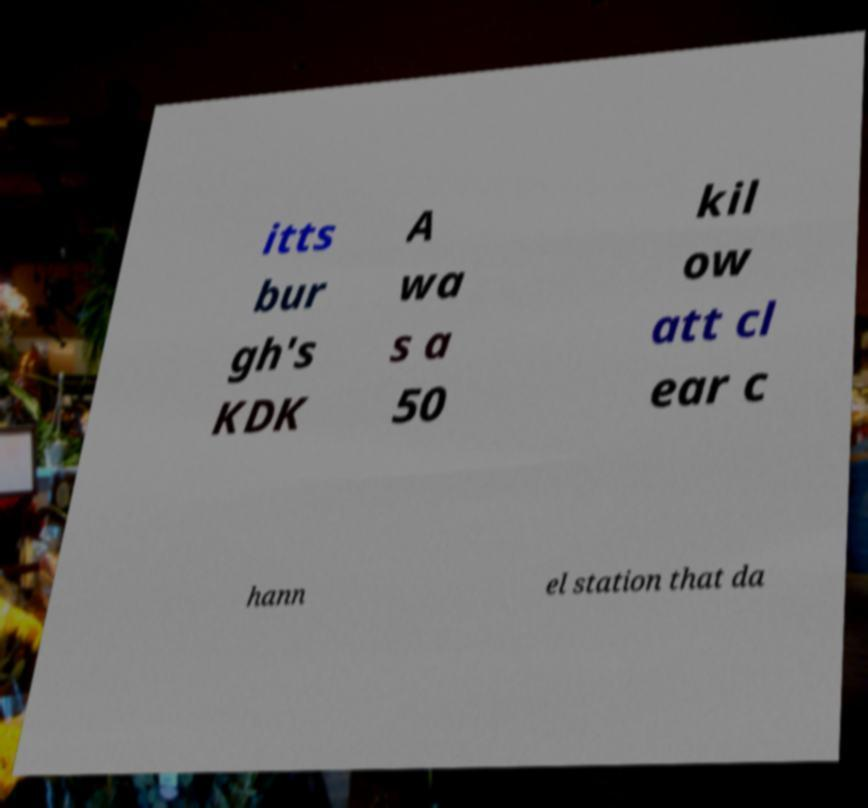What messages or text are displayed in this image? I need them in a readable, typed format. itts bur gh's KDK A wa s a 50 kil ow att cl ear c hann el station that da 